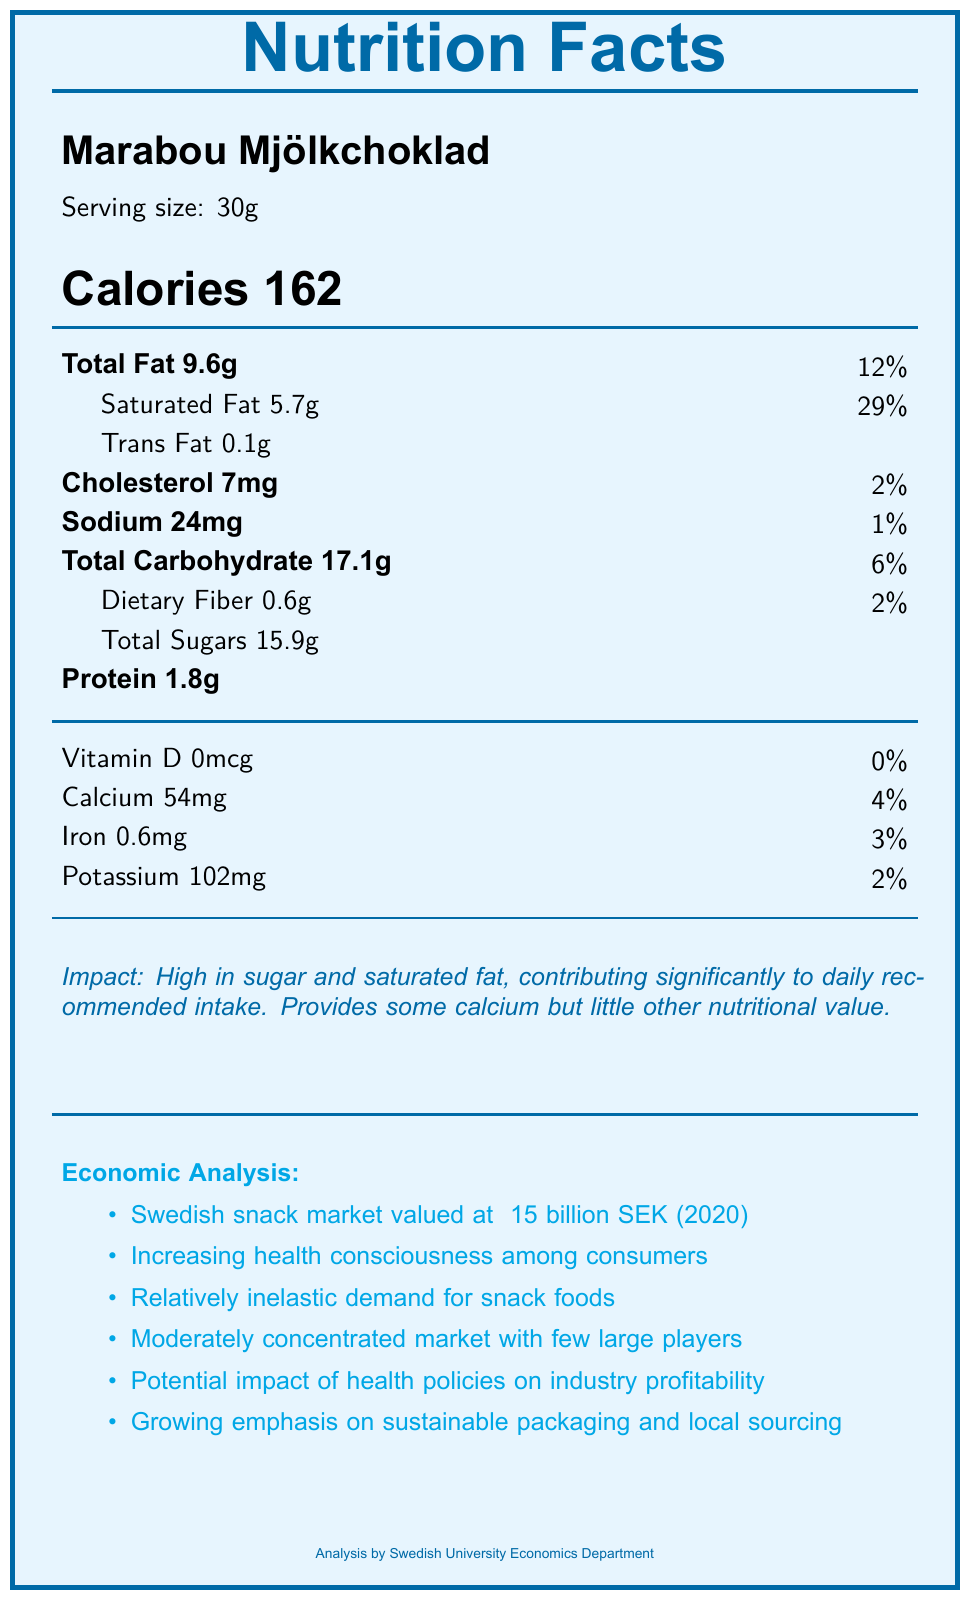What is the serving size of Marabou Mjölkchoklad? It is stated in the document next to the snack name Marabou Mjölkchoklad, mentioning "Serving size: 30g".
Answer: 30g How many calories are there in a serving of OLW Sourcream & Onion Chips? The document states "Calories 156" under the OLW Sourcream & Onion Chips section.
Answer: 156 What is the primary concern regarding the nutritional impact of Cloetta Kexchoklad? The document mentions, "High in calories, sugar, and saturated fat. Significant contribution to daily sugar intake. Provides some calcium and iron."
Answer: High in calories, sugar, and saturated fat. Which snack has the highest sodium content? According to the document, OLW Sourcream & Onion Chips have 180mg of sodium, which is the highest compared to other snacks listed.
Answer: OLW Sourcream & Onion Chips What percentage of daily recommended iron intake is provided by Wasabröd Rågi? The document specifies that Wasabröd Rågi provides 0.6mg of iron, which corresponds to 3% of the daily recommended intake.
Answer: 3% Which snack is mentioned as having a good source of fiber? A. Marabou Mjölkchoklad B. OLW Sourcream & Onion Chips C. Göteborgs Ballerina Originalkakor D. Wasabröd Rågi Wasabröd Rågi is described as "Good source of fiber" in the document.
Answer: D. Wasabröd Rågi Which of the following statements is true about the Swedish snack market's demand elasticity? 1. Perfectly elastic 2. Elastic 3. Inelastic 4. Unit elastic The document mentions "Snack foods typically have relatively inelastic demand, with price changes having minimal impact on consumption patterns."
Answer: 3. Inelastic Are Swedish consumers increasingly health-conscious about their snack choices? The document states, "Swedish consumers are increasingly health-conscious, influencing snack choices and creating demand for healthier alternatives."
Answer: Yes What is the main idea of the economic analysis part of the document? The economic analysis section includes details on market value, consumer behavior, price elasticity, market concentration, health policy impacts, and sustainability concerns.
Answer: The Swedish snack market is growing, shows inelastic demand, and is impacted by consumer health consciousness and potential health policies. What is the exact process used to calculate recommended daily values for nutrients? The document does not provide information on how recommended daily values for nutrients are calculated.
Answer: Cannot be determined Provide a brief summary of the nutritional impact and economic analysis of common Swedish snacks. The summary encapsulates both the nutritional facts and economic implications described in the document. The nutritional content and its effects on health are assessed, along with a comprehensive view of the market dynamics and consumer behaviors in the Swedish snack industry.
Answer: The document assesses the nutritional content of various Swedish snacks, highlighting their contribution to daily intake of calories, fats, sugars, and other nutrients. It also includes an economic analysis, focusing on the Swedish snack market's size, consumer health trends, demand characteristics, market concentration, potential impacts of health policies, and sustainability issues. 